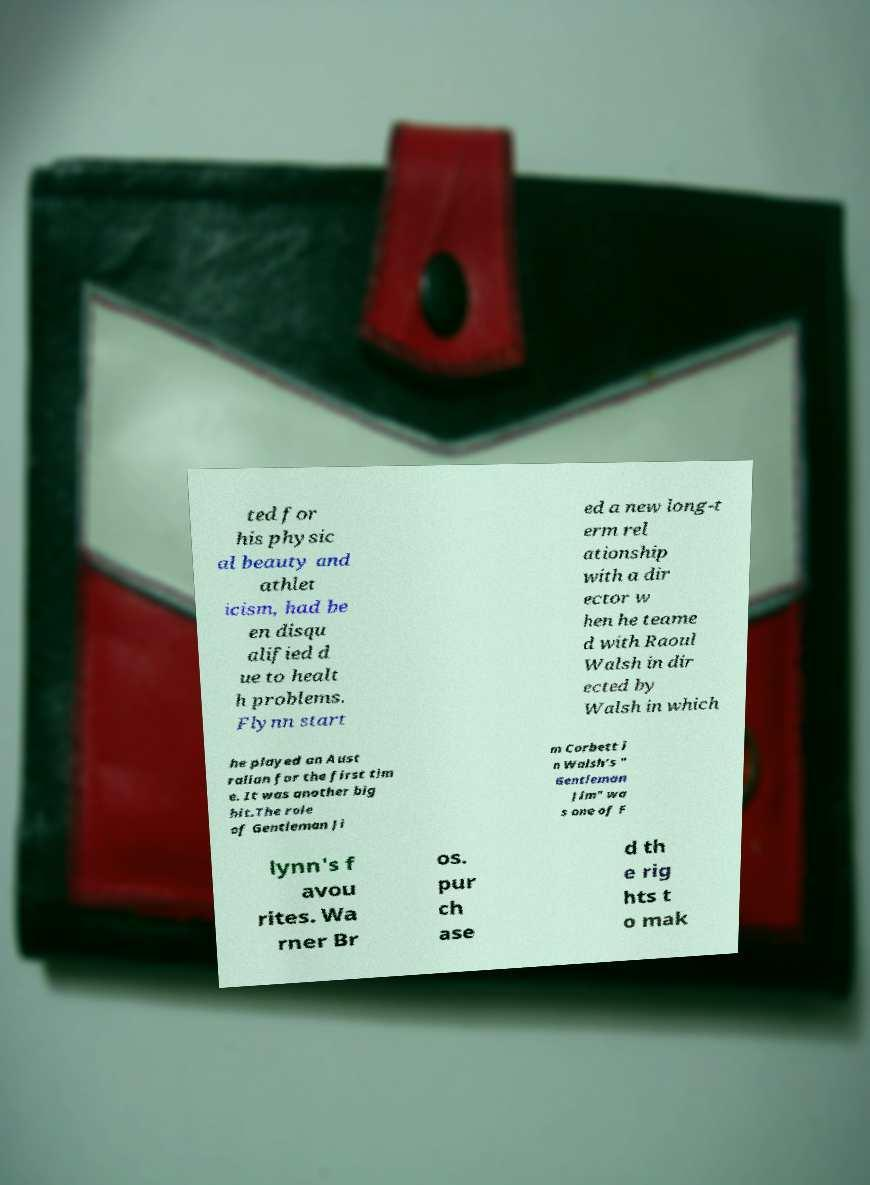Can you accurately transcribe the text from the provided image for me? ted for his physic al beauty and athlet icism, had be en disqu alified d ue to healt h problems. Flynn start ed a new long-t erm rel ationship with a dir ector w hen he teame d with Raoul Walsh in dir ected by Walsh in which he played an Aust ralian for the first tim e. It was another big hit.The role of Gentleman Ji m Corbett i n Walsh's " Gentleman Jim" wa s one of F lynn's f avou rites. Wa rner Br os. pur ch ase d th e rig hts t o mak 